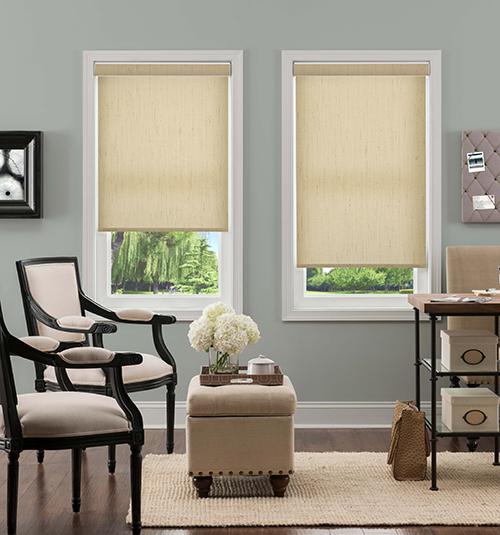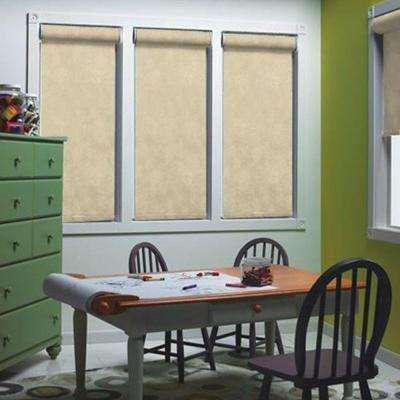The first image is the image on the left, the second image is the image on the right. For the images displayed, is the sentence "All the shades are partially open." factually correct? Answer yes or no. No. The first image is the image on the left, the second image is the image on the right. Analyze the images presented: Is the assertion "There are two windows in the left image." valid? Answer yes or no. Yes. 